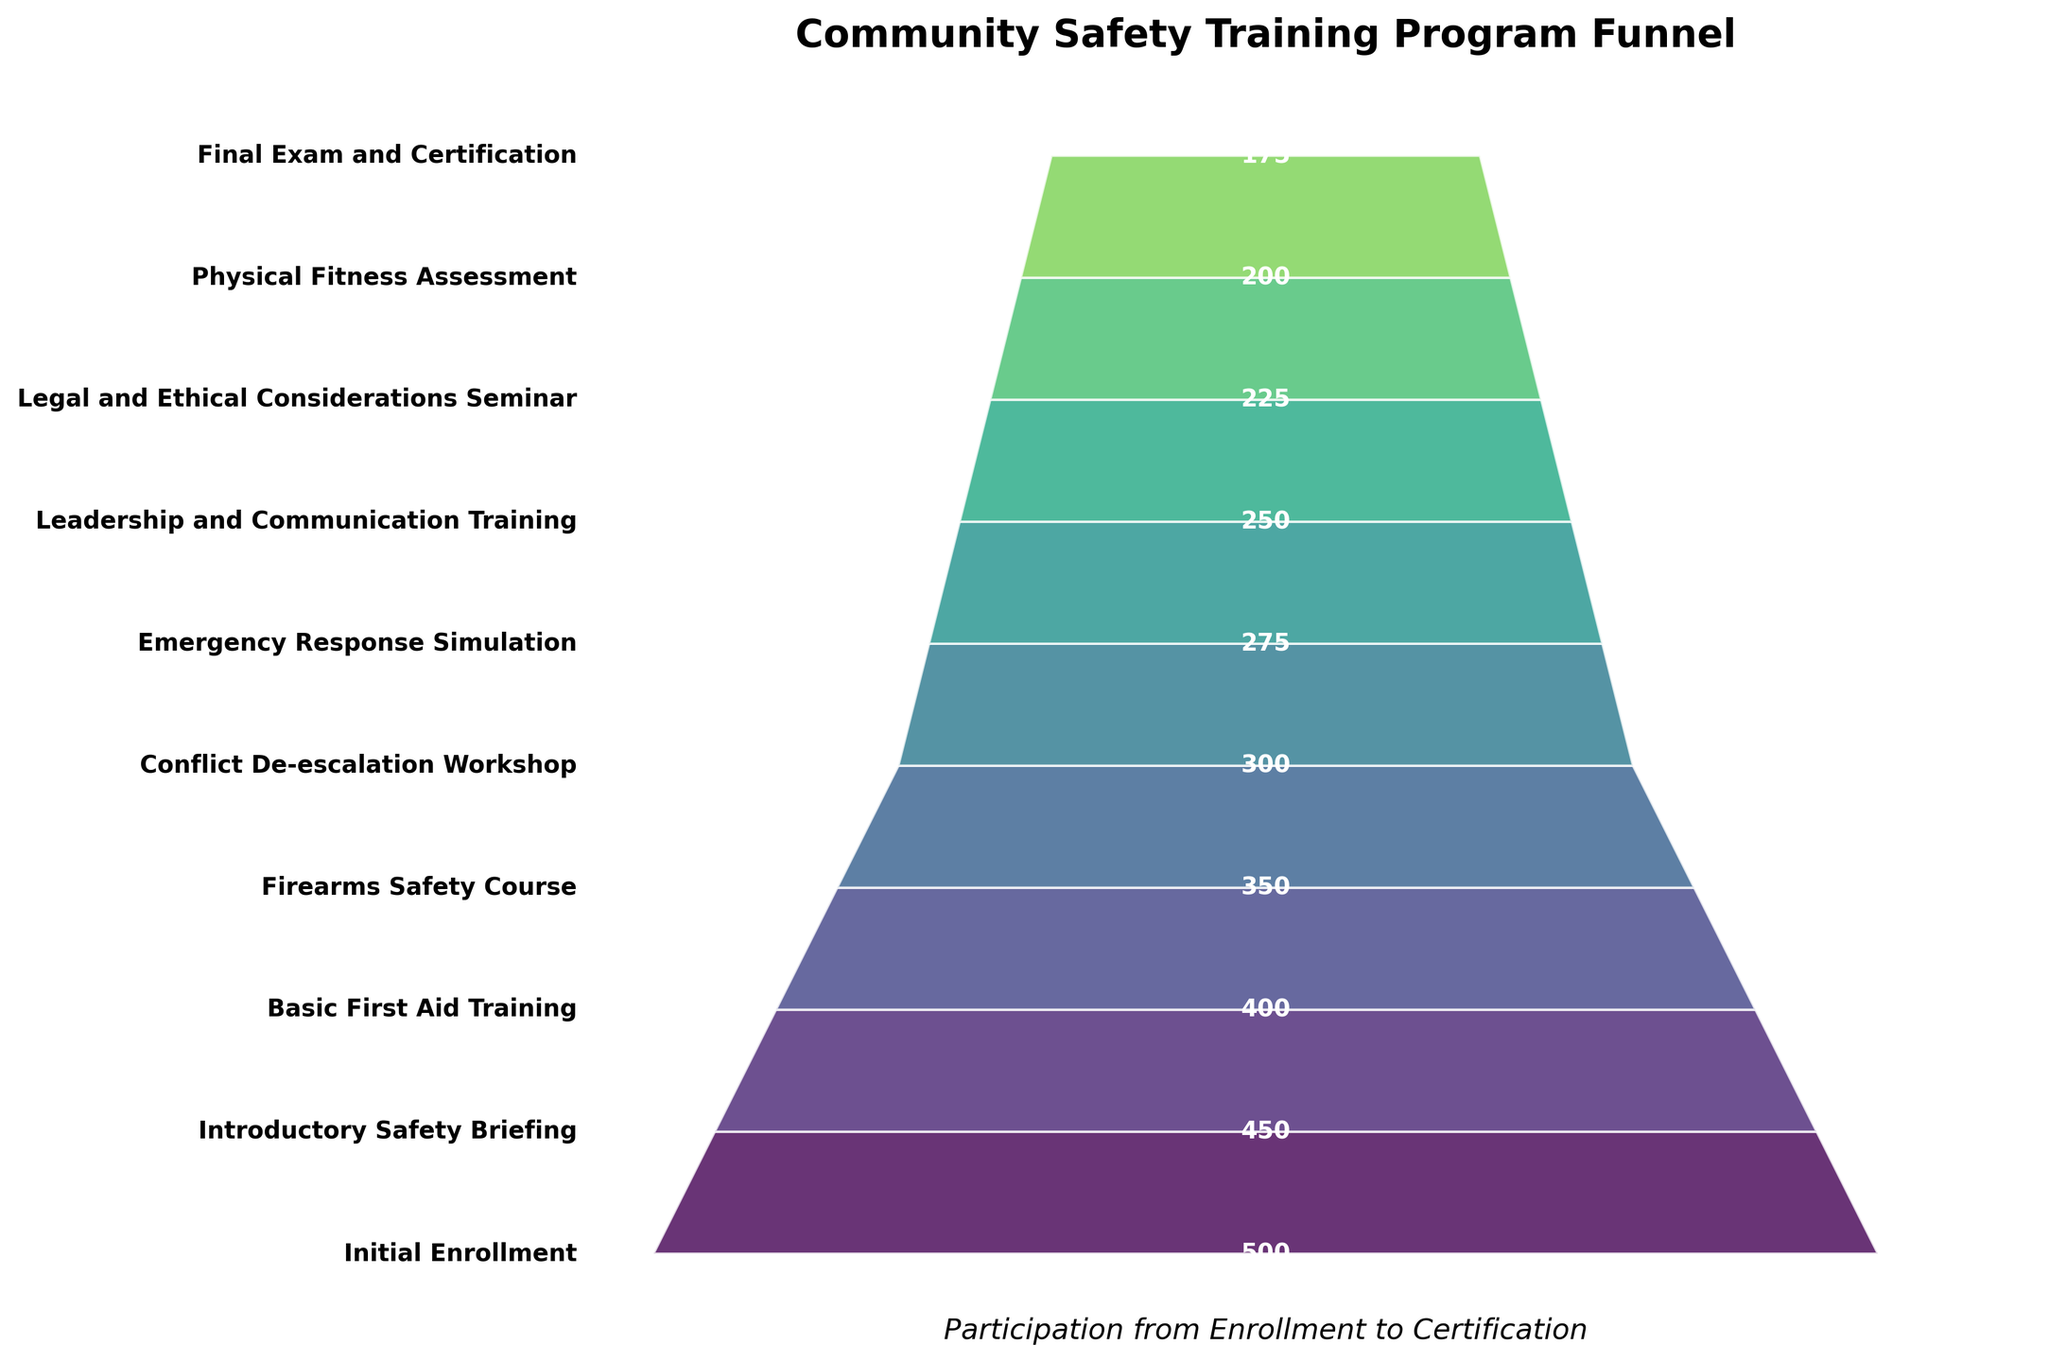What's the title of the funnel chart? The title is typically found at the top of the figure and is a summary of what the chart represents. Here, it reads "Community Safety Training Program Funnel".
Answer: Community Safety Training Program Funnel How many stages are depicted in the funnel chart? Count the unique stages listed on the y-axis from top to bottom. There are 10 stages in total.
Answer: 10 How many participants completed the Final Exam and Certification stage? Look for the participants' number listed next to the "Final Exam and Certification" label. It is marked as 175.
Answer: 175 What is the decrease in participants from the Basic First Aid Training stage to the Firearms Safety Course stage? Subtract the number of participants in the "Firearms Safety Course" stage (350) from those in the "Basic First Aid Training" stage (400). The calculation is 400 - 350 = 50.
Answer: 50 How many participants dropped out between the Initial Enrollment and the Final Exam and Certification stages? Subtract the number of participants at the final stage (175) from the initial enrollment stage (500). The calculation is 500 - 175 = 325.
Answer: 325 Which stage has the highest number of participants? The highest number is typically at the top of the funnel. Here, it is the "Initial Enrollment" stage with 500 participants.
Answer: Initial Enrollment By what percentage did the number of participants decrease from the Introductory Safety Briefing to the Basic First Aid Training? Use the formula for percentage decrease: (Initial Number - Final Number) / Initial Number * 100. For the Introductory Safety Briefing (450) to Basic First Aid Training (400), it’s (450 - 400) / 450 * 100 = 11.11%.
Answer: 11.11% Which stage experienced the biggest drop in participants? Compare the differences between consecutive stages. The largest drop is between the Initial Enrollment (500) and the Introductory Safety Briefing (450), which is a drop of 50.
Answer: Initial Enrollment to Introductory Safety Briefing What is the average number of participants across all stages? Add participant numbers from all stages and divide by the total number of stages. The sum is 500 + 450 + 400 + 350 + 300 + 275 + 250 + 225 + 200 + 175 = 3,125. The average is 3,125 / 10 = 312.5.
Answer: 312.5 Compare the number of participants in Conflict De-escalation Workshop and Physical Fitness Assessment. Which stage has more participants and by how many? The Conflict De-escalation Workshop has 300 participants while the Physical Fitness Assessment has 200. Subtract 200 from 300 to find the difference. 300 - 200 = 100. The Conflict De-escalation Workshop has 100 more.
Answer: Conflict De-escalation Workshop by 100 